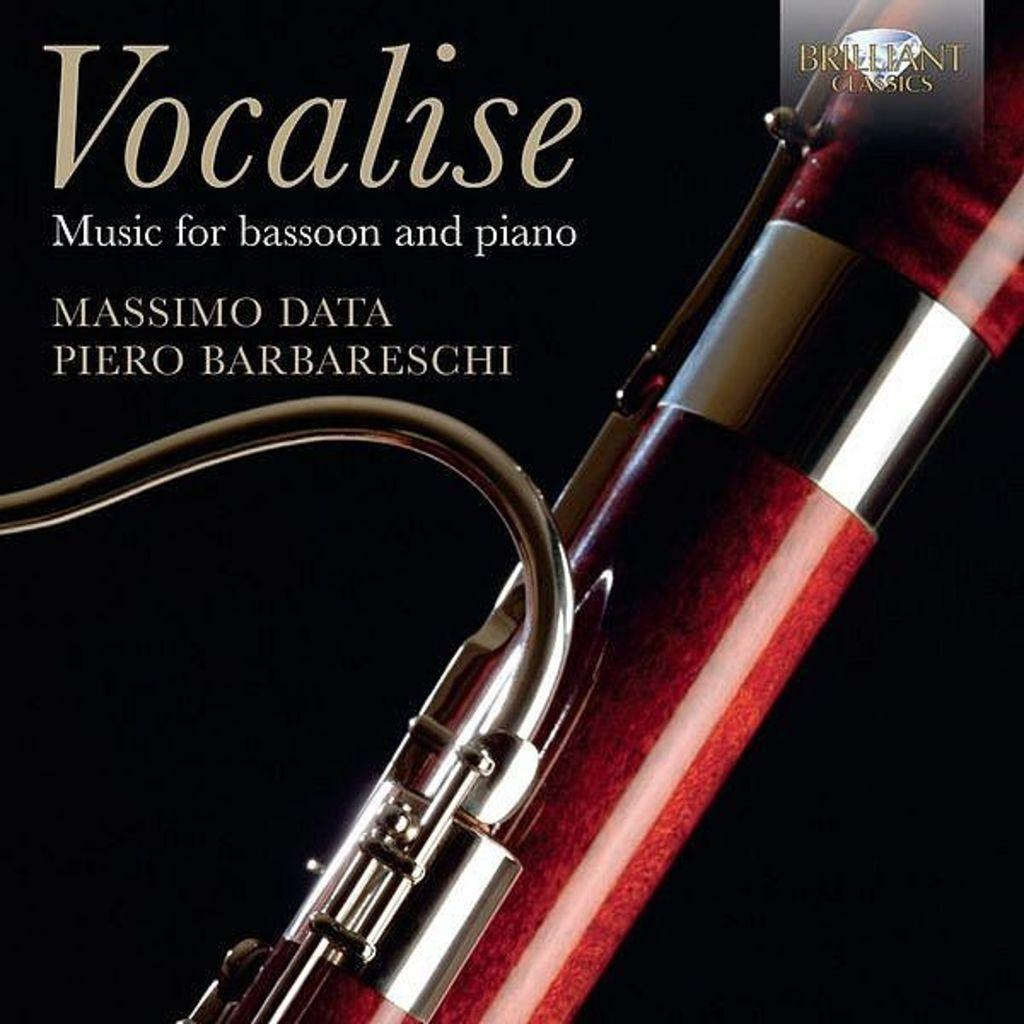What is the main subject in the foreground of the image? There is a musical instrument in the foreground of the image. What else can be seen in the image besides the musical instrument? There is some text visible at the top of the image. What is the price of the musical instrument in the image? The price of the musical instrument is not mentioned in the image, so it cannot be determined. 